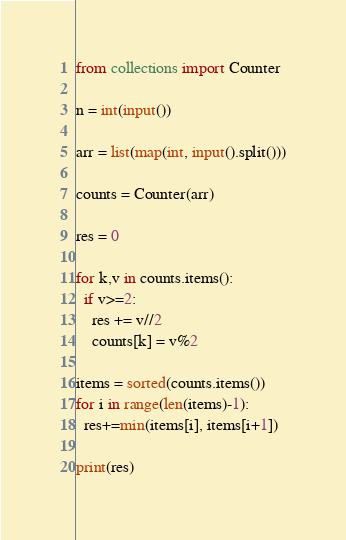Convert code to text. <code><loc_0><loc_0><loc_500><loc_500><_Python_>from collections import Counter
 
n = int(input())
 
arr = list(map(int, input().split()))
 
counts = Counter(arr)
 
res = 0
 
for k,v in counts.items():
  if v>=2:
    res += v//2
    counts[k] = v%2
    
items = sorted(counts.items())
for i in range(len(items)-1):
  res+=min(items[i], items[i+1])
  
print(res)</code> 